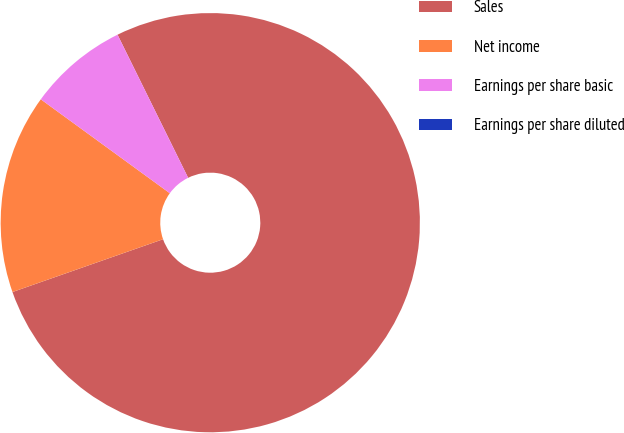Convert chart. <chart><loc_0><loc_0><loc_500><loc_500><pie_chart><fcel>Sales<fcel>Net income<fcel>Earnings per share basic<fcel>Earnings per share diluted<nl><fcel>76.92%<fcel>15.38%<fcel>7.69%<fcel>0.0%<nl></chart> 